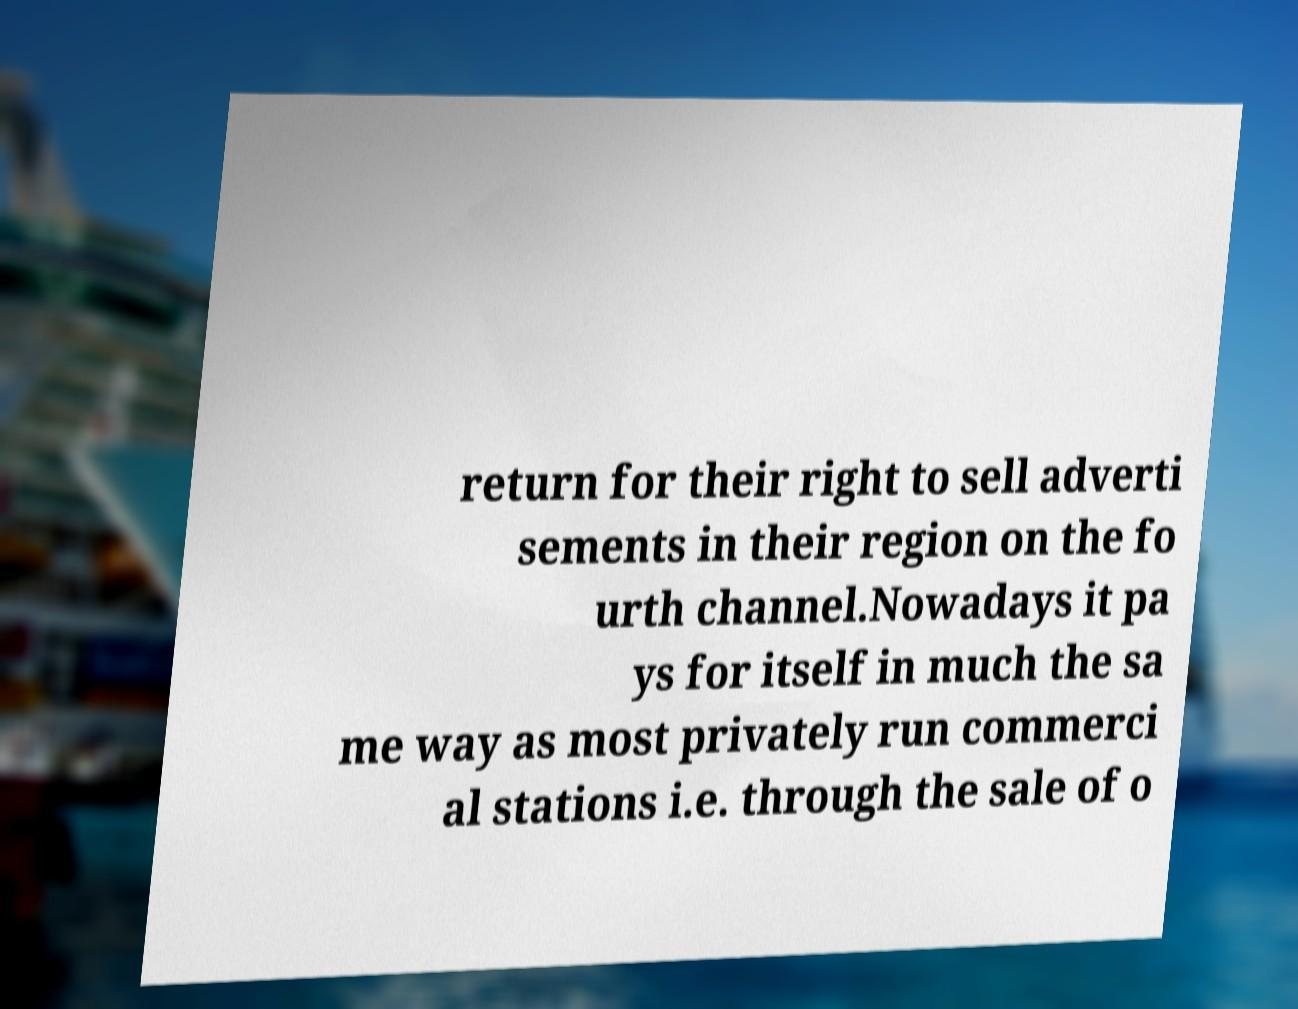Please identify and transcribe the text found in this image. return for their right to sell adverti sements in their region on the fo urth channel.Nowadays it pa ys for itself in much the sa me way as most privately run commerci al stations i.e. through the sale of o 